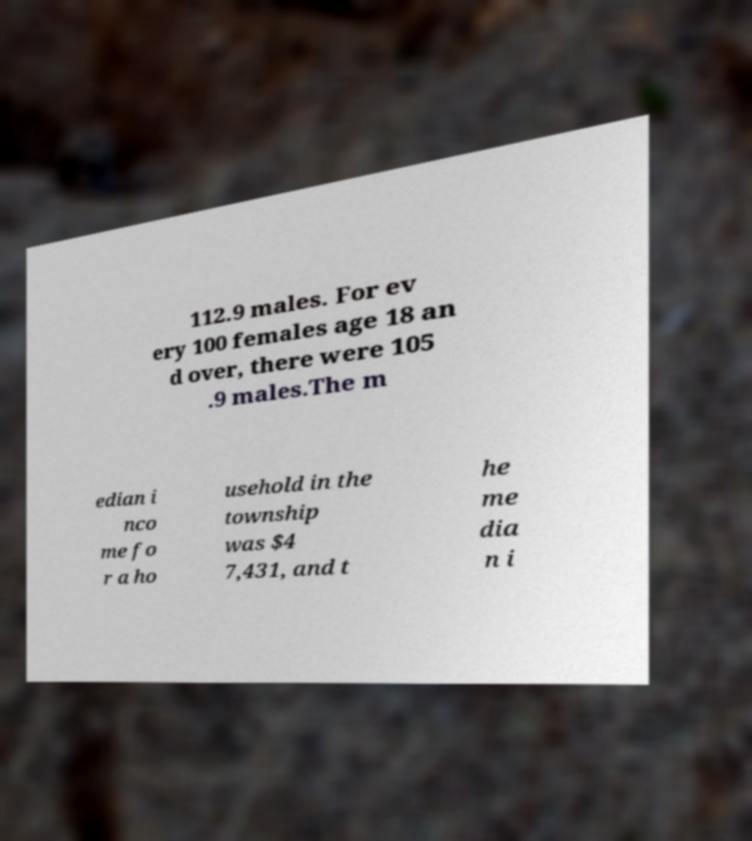Can you read and provide the text displayed in the image?This photo seems to have some interesting text. Can you extract and type it out for me? 112.9 males. For ev ery 100 females age 18 an d over, there were 105 .9 males.The m edian i nco me fo r a ho usehold in the township was $4 7,431, and t he me dia n i 